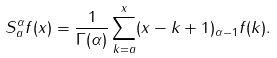<formula> <loc_0><loc_0><loc_500><loc_500>S _ { a } ^ { \alpha } f ( x ) = \frac { 1 } { \Gamma ( \alpha ) } \sum _ { k = a } ^ { x } ( x - k + 1 ) _ { \alpha - 1 } f ( k ) .</formula> 